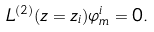Convert formula to latex. <formula><loc_0><loc_0><loc_500><loc_500>L ^ { ( 2 ) } ( z = z _ { i } ) \varphi ^ { i } _ { m } = 0 .</formula> 